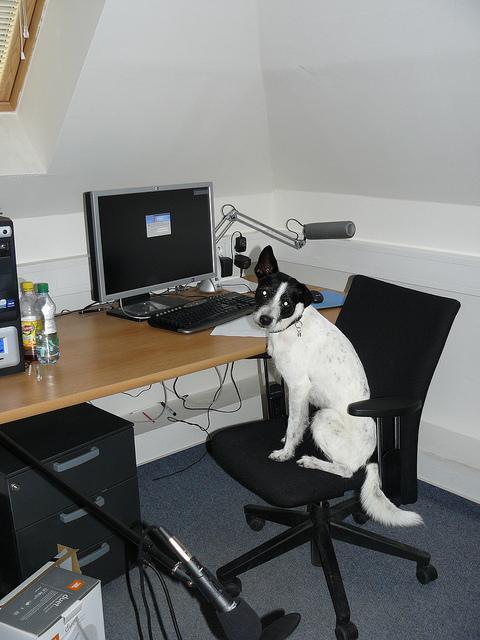How many coffee cups can you see?
Give a very brief answer. 0. 